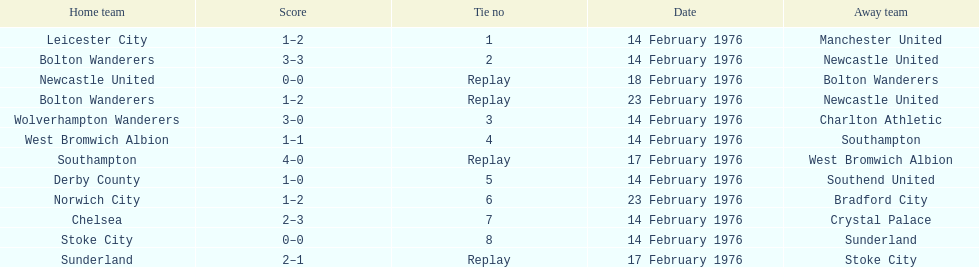How many games were replays? 4. 